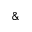<formula> <loc_0><loc_0><loc_500><loc_500>\&</formula> 